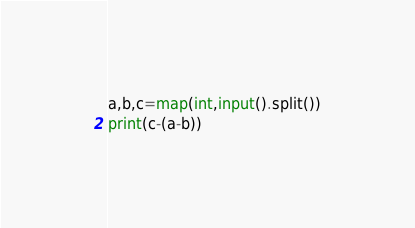<code> <loc_0><loc_0><loc_500><loc_500><_Python_>a,b,c=map(int,input().split())
print(c-(a-b))</code> 